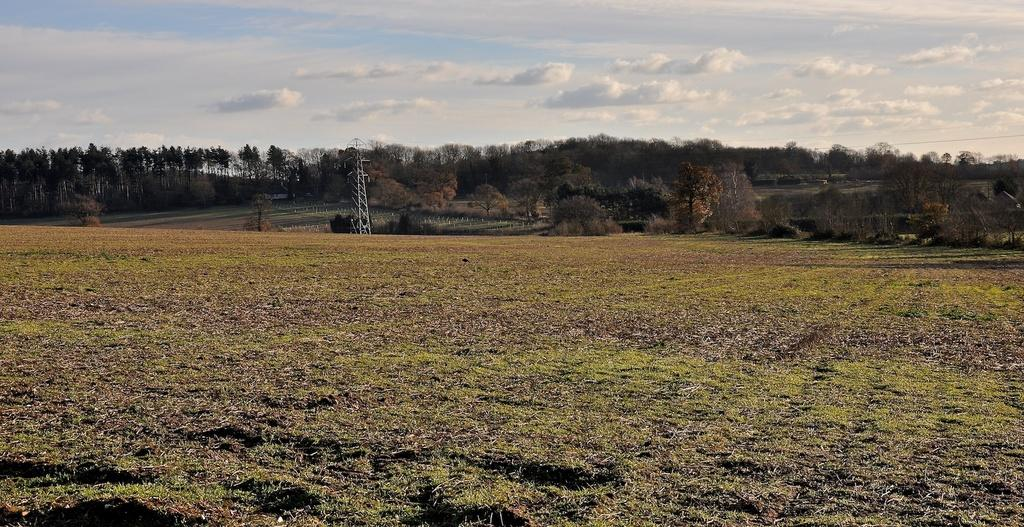What is the main setting of the image? There is a field in the image. What can be seen in the background of the field? There is a tower and trees in the background of the image. What is visible in the sky in the image? The sky is visible in the background of the image. How much profit did the kittens make from selling the crops in the field? There are no kittens or crops present in the image, so it is not possible to determine any profit made. 